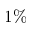Convert formula to latex. <formula><loc_0><loc_0><loc_500><loc_500>1 \%</formula> 